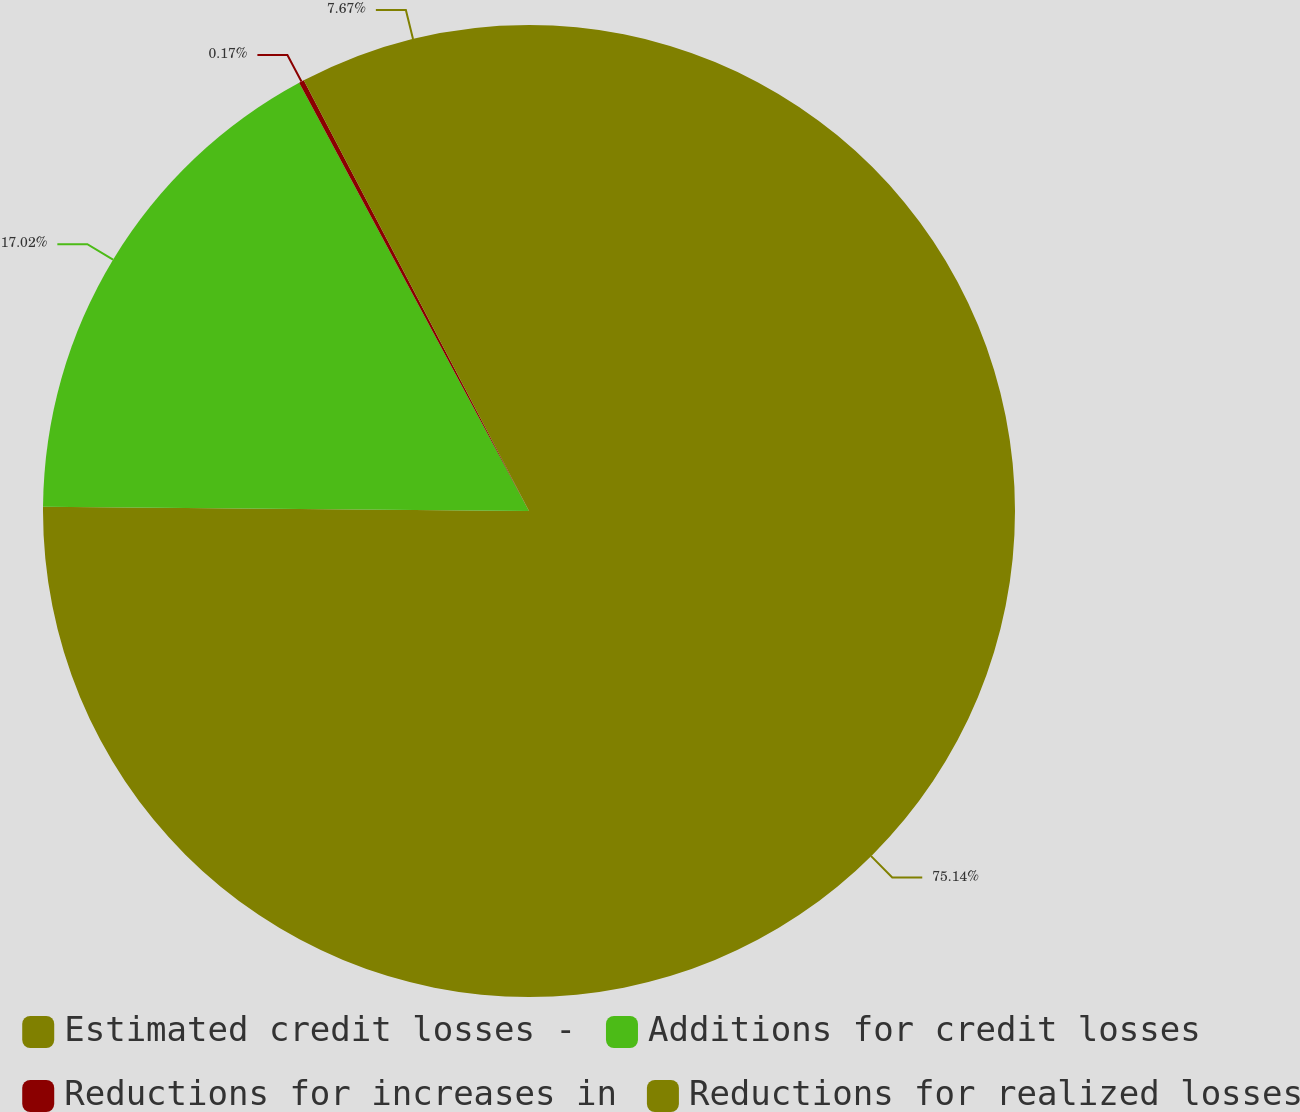Convert chart. <chart><loc_0><loc_0><loc_500><loc_500><pie_chart><fcel>Estimated credit losses -<fcel>Additions for credit losses<fcel>Reductions for increases in<fcel>Reductions for realized losses<nl><fcel>75.14%<fcel>17.02%<fcel>0.17%<fcel>7.67%<nl></chart> 